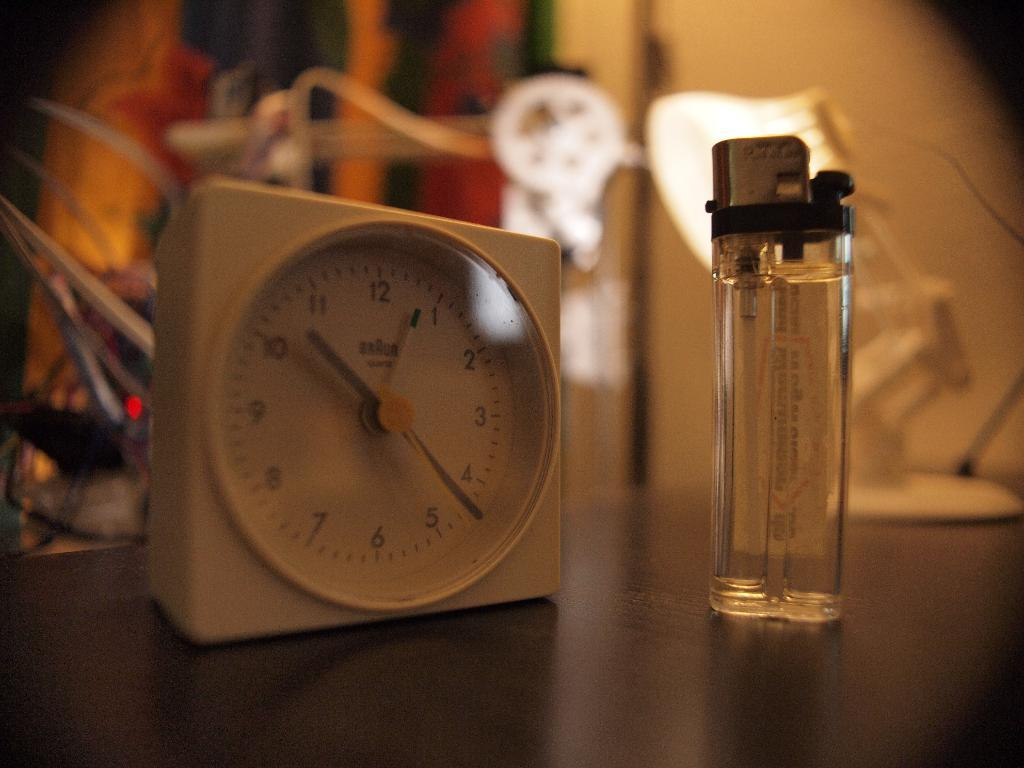<image>
Provide a brief description of the given image. The small white clock next to the lighter reads 10:23. 